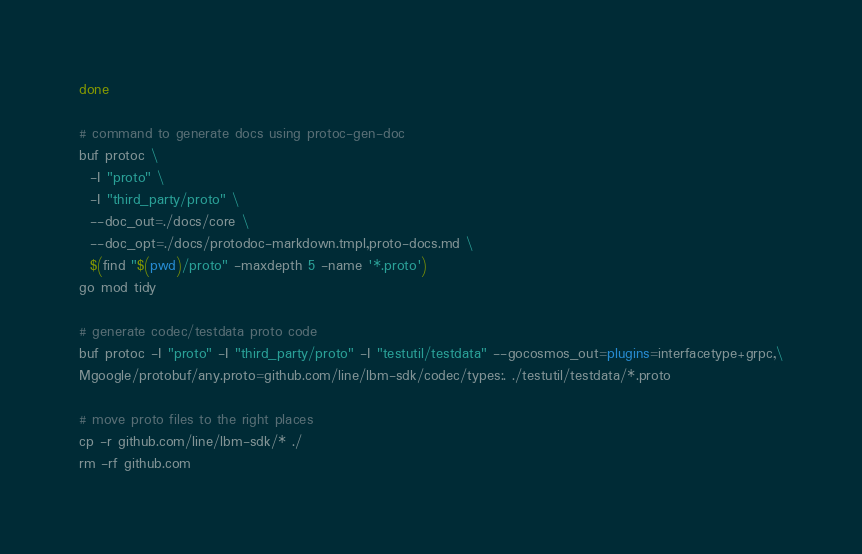Convert code to text. <code><loc_0><loc_0><loc_500><loc_500><_Bash_>
done

# command to generate docs using protoc-gen-doc
buf protoc \
  -I "proto" \
  -I "third_party/proto" \
  --doc_out=./docs/core \
  --doc_opt=./docs/protodoc-markdown.tmpl,proto-docs.md \
  $(find "$(pwd)/proto" -maxdepth 5 -name '*.proto')
go mod tidy

# generate codec/testdata proto code
buf protoc -I "proto" -I "third_party/proto" -I "testutil/testdata" --gocosmos_out=plugins=interfacetype+grpc,\
Mgoogle/protobuf/any.proto=github.com/line/lbm-sdk/codec/types:. ./testutil/testdata/*.proto

# move proto files to the right places
cp -r github.com/line/lbm-sdk/* ./
rm -rf github.com
</code> 